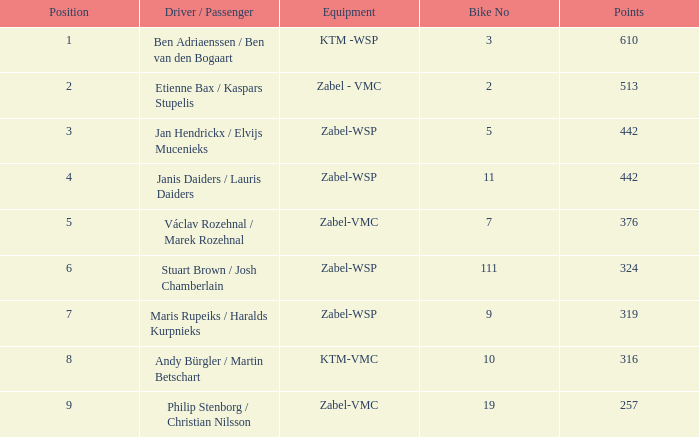What are the points for ktm-vmc equipment?  316.0. 